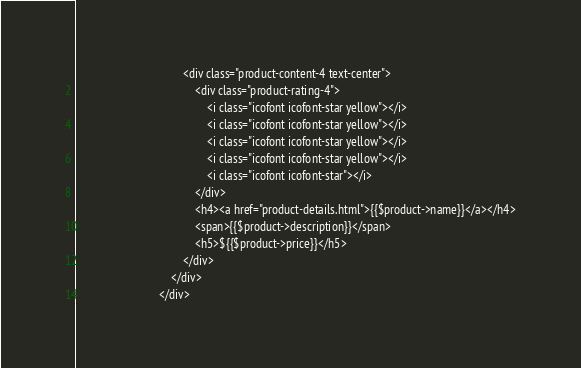Convert code to text. <code><loc_0><loc_0><loc_500><loc_500><_PHP_>                                    <div class="product-content-4 text-center">
                                        <div class="product-rating-4">
                                            <i class="icofont icofont-star yellow"></i>
                                            <i class="icofont icofont-star yellow"></i>
                                            <i class="icofont icofont-star yellow"></i>
                                            <i class="icofont icofont-star yellow"></i>
                                            <i class="icofont icofont-star"></i>
                                        </div>
                                        <h4><a href="product-details.html">{{$product->name}}</a></h4>
                                        <span>{{$product->description}}</span>
                                        <h5>${{$product->price}}</h5>
                                    </div>
                                </div>
                            </div></code> 